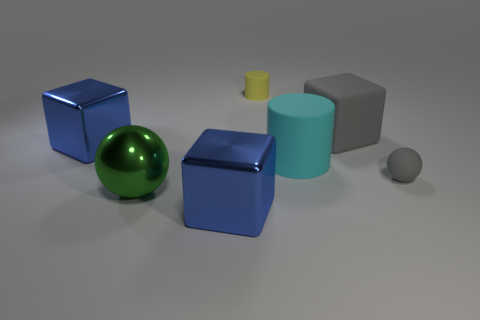What number of objects are either green metallic balls in front of the big gray matte thing or blue metallic objects in front of the cyan matte cylinder?
Provide a succinct answer. 2. Do the sphere that is on the left side of the gray rubber block and the yellow rubber object have the same size?
Give a very brief answer. No. There is a small object that is in front of the cyan object; what color is it?
Provide a short and direct response. Gray. There is another big rubber object that is the same shape as the yellow rubber thing; what color is it?
Make the answer very short. Cyan. How many blue things are in front of the rubber cylinder that is in front of the gray object that is left of the small gray ball?
Offer a terse response. 1. Is there anything else that has the same material as the green sphere?
Make the answer very short. Yes. Are there fewer large green things that are behind the large gray rubber thing than small yellow metal blocks?
Give a very brief answer. No. Does the big ball have the same color as the large rubber cube?
Give a very brief answer. No. There is a green object that is the same shape as the tiny gray rubber thing; what is its size?
Keep it short and to the point. Large. How many large gray blocks have the same material as the tiny gray sphere?
Make the answer very short. 1. 